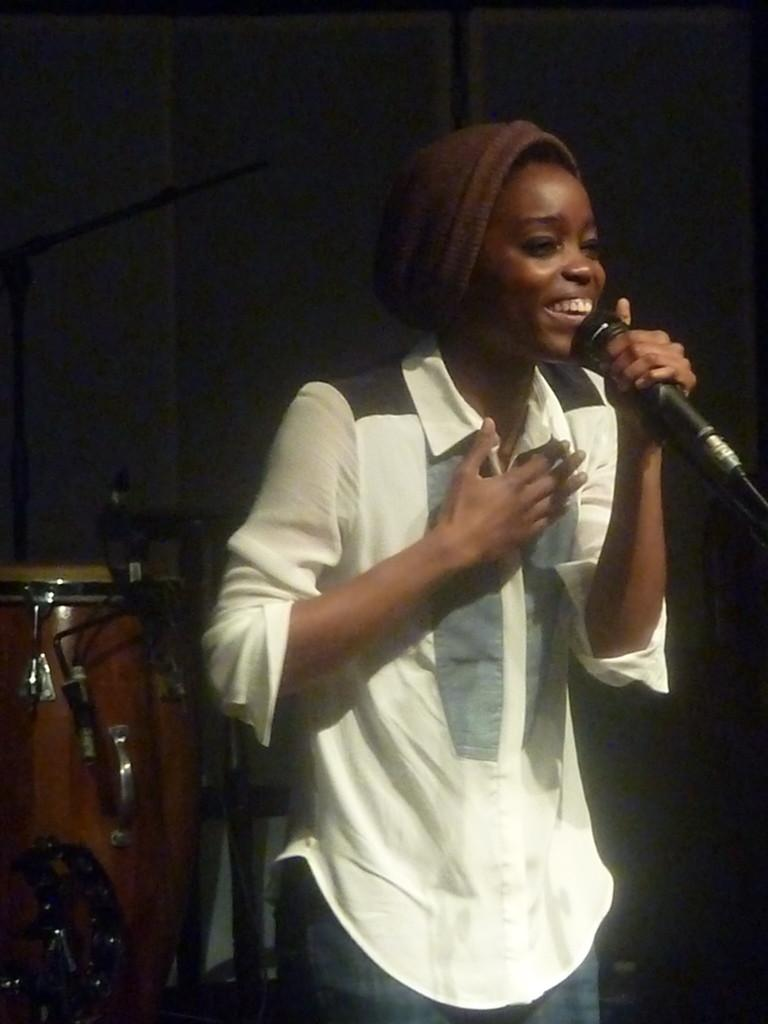What is the woman in the image holding? The woman is holding a mic. Can you describe the woman's attire in the image? The woman is wearing a wire cap. What object related to music can be seen in the image? There is a musical instrument visible in the image. What might the woman be doing in the image? The woman is likely to be singing or performing. What type of fuel is the woman using to power her performance in the image? There is no indication in the image that the woman is using any fuel to power her performance. Can you tell me how many poisonous plants are visible in the image? There are no poisonous plants visible in the image. What type of vegetable is the woman holding in the image? The woman is holding a mic, not a vegetable, in the image. 